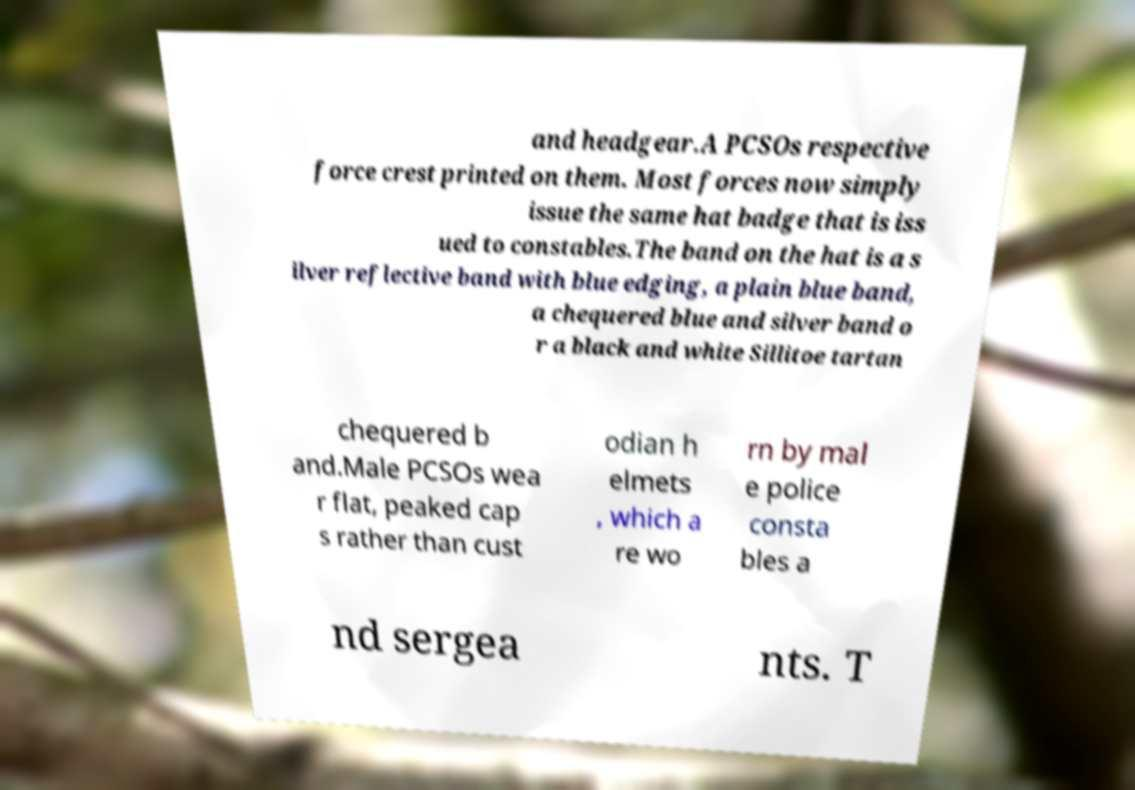There's text embedded in this image that I need extracted. Can you transcribe it verbatim? and headgear.A PCSOs respective force crest printed on them. Most forces now simply issue the same hat badge that is iss ued to constables.The band on the hat is a s ilver reflective band with blue edging, a plain blue band, a chequered blue and silver band o r a black and white Sillitoe tartan chequered b and.Male PCSOs wea r flat, peaked cap s rather than cust odian h elmets , which a re wo rn by mal e police consta bles a nd sergea nts. T 